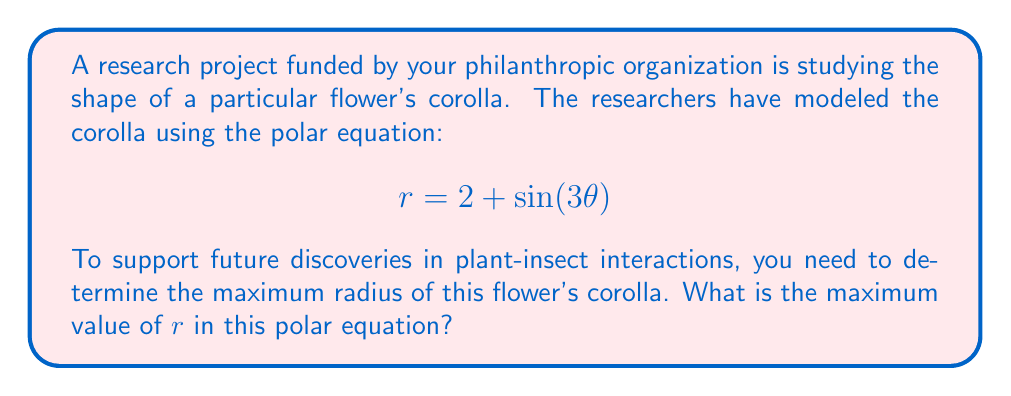Give your solution to this math problem. To find the maximum radius of the flower's corolla, we need to determine the maximum value of $r$ in the given polar equation.

1) The equation is in the form: $r = 2 + \sin(3\theta)$

2) We know that the sine function oscillates between -1 and 1. Therefore, $\sin(3\theta)$ will also oscillate between -1 and 1, regardless of the value of $\theta$.

3) The maximum value of $r$ will occur when $\sin(3\theta)$ is at its maximum, which is 1.

4) So, the maximum value of $r$ is:

   $$r_{max} = 2 + 1 = 3$$

5) To visualize this, we can plot the equation:

[asy]
import graph;
size(200);
real r(real t) {return 2+sin(3*t);}
path g=polargraph(r,0,2pi);
draw(g);
dot((3,0),red);
label("$r_{max}$", (3,0), E, red);
[/asy]

The red dot indicates the maximum radius, which occurs when the curve is farthest from the origin.

This maximum radius is crucial for understanding the flower's structure and its potential interactions with insects, supporting the organization's focus on plant-insect interactions.
Answer: The maximum radius of the flower's corolla is 3 units. 